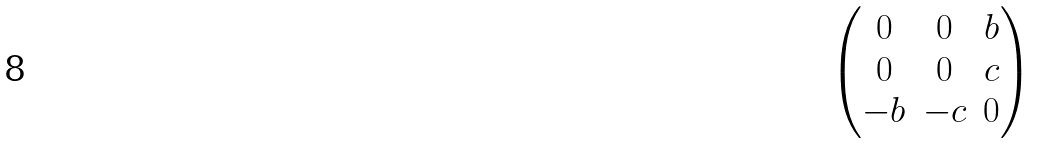<formula> <loc_0><loc_0><loc_500><loc_500>\begin{pmatrix} 0 & 0 & b \\ 0 & 0 & c \\ - b & - c & 0 \end{pmatrix}</formula> 